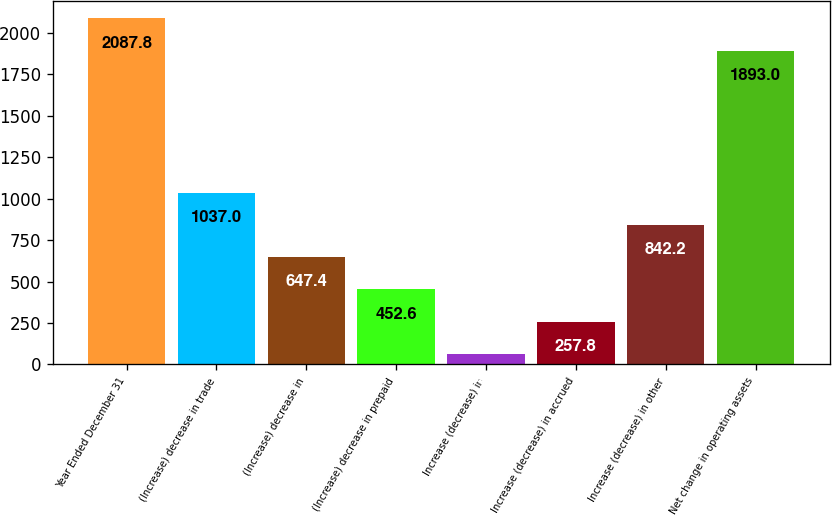<chart> <loc_0><loc_0><loc_500><loc_500><bar_chart><fcel>Year Ended December 31<fcel>(Increase) decrease in trade<fcel>(Increase) decrease in<fcel>(Increase) decrease in prepaid<fcel>Increase (decrease) in<fcel>Increase (decrease) in accrued<fcel>Increase (decrease) in other<fcel>Net change in operating assets<nl><fcel>2087.8<fcel>1037<fcel>647.4<fcel>452.6<fcel>63<fcel>257.8<fcel>842.2<fcel>1893<nl></chart> 